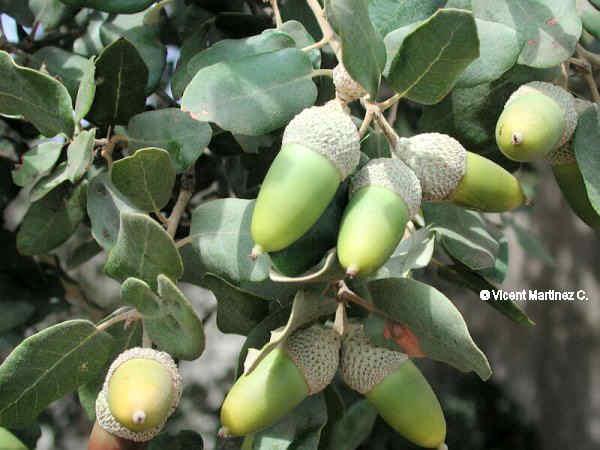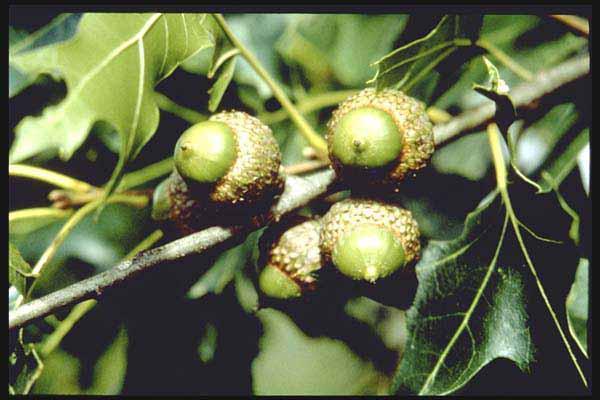The first image is the image on the left, the second image is the image on the right. Considering the images on both sides, is "Acorns are growing on trees in each of the images." valid? Answer yes or no. Yes. The first image is the image on the left, the second image is the image on the right. Considering the images on both sides, is "Each image shows acorns growing on a tree with green leaves, and in total, most acorns are green and most acorns are slender." valid? Answer yes or no. Yes. 